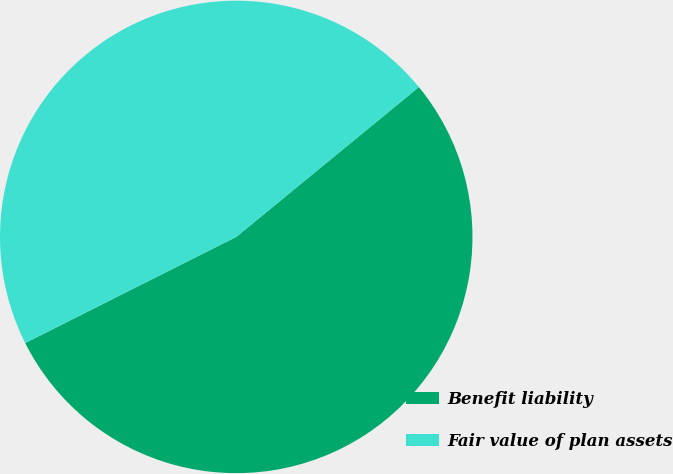Convert chart. <chart><loc_0><loc_0><loc_500><loc_500><pie_chart><fcel>Benefit liability<fcel>Fair value of plan assets<nl><fcel>53.52%<fcel>46.48%<nl></chart> 